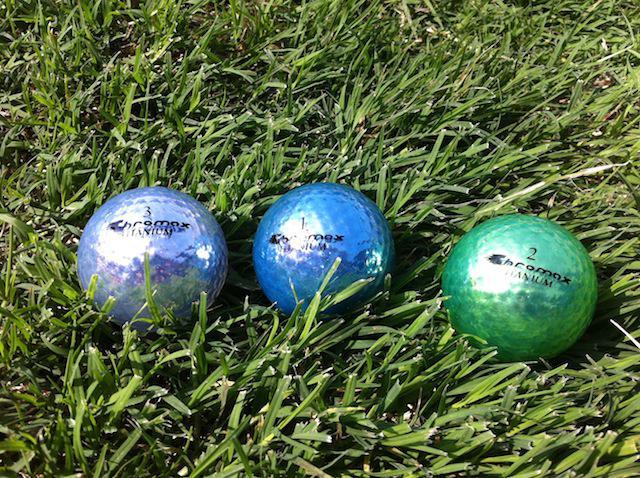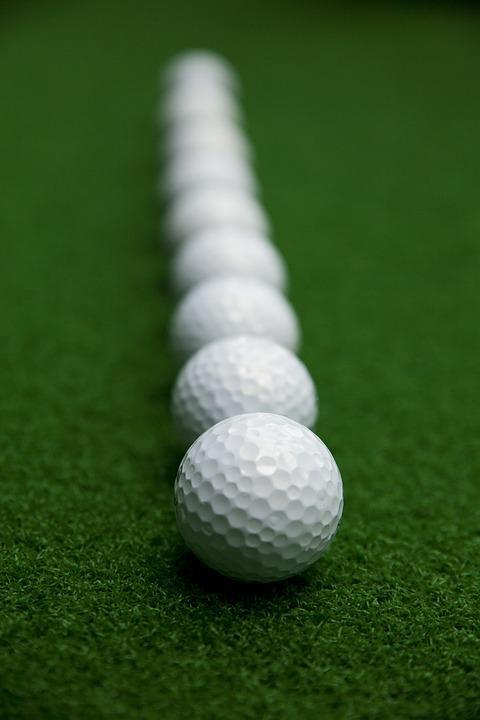The first image is the image on the left, the second image is the image on the right. For the images shown, is this caption "Exactly four golf balls are arranged on grass in one image." true? Answer yes or no. No. The first image is the image on the left, the second image is the image on the right. For the images shown, is this caption "in 1 of the images, 1 white golf ball is sitting in grass." true? Answer yes or no. No. 